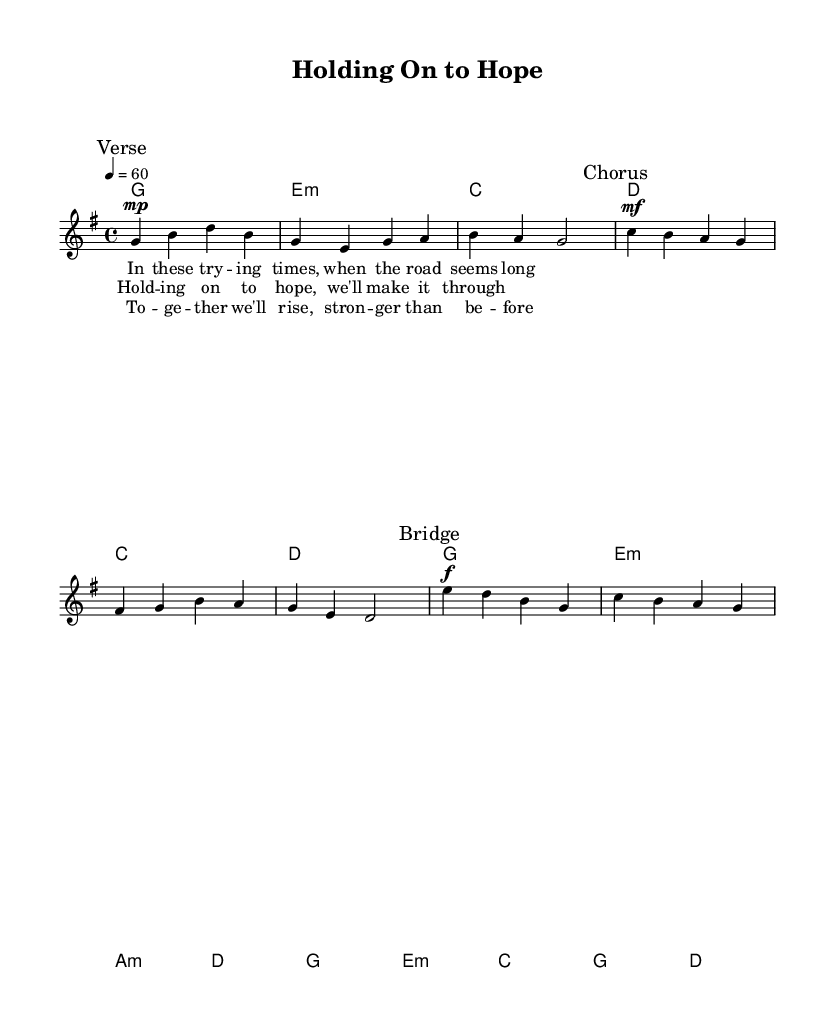What is the key signature of this music? The key signature is G major, which has one sharp (F#). You can determine this by looking at the key signature indicated at the beginning of the score.
Answer: G major What is the time signature of this music? The time signature is 4/4, also known as common time. This is indicated in the upper left corner of the score after the key signature.
Answer: 4/4 What is the tempo marking indicated in the piece? The tempo marking is quarter note equals 60, which is indicated at the beginning of the score. This specifies the speed of the piece.
Answer: 60 How many measures are in the verse section? The verse section has a total of three measures. This can be counted from the music notation in the verse section marked as "Verse."
Answer: 3 What dynamic marking is used at the beginning of the verse? The dynamic marking is mezzo-piano (mp). This is noted at the start of the verse section and indicates a moderate soft volume.
Answer: mezzo-piano What is the main theme expressed in the chorus? The main theme expressed in the chorus is hope and perseverance. This can be inferred from the lyrics that convey a message of holding on to hope during difficult times.
Answer: hope and perseverance How many chords are in the chorus? There are six chords in the chorus section. This can be determined by counting the chord symbols placed above the melody notes in the chorus.
Answer: 6 